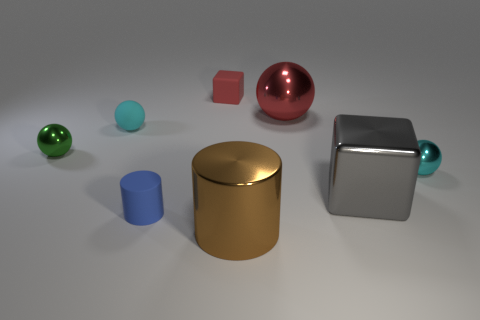Subtract all cyan shiny spheres. How many spheres are left? 3 Add 1 tiny things. How many objects exist? 9 Subtract all red balls. How many balls are left? 3 Subtract all gray blocks. How many cyan balls are left? 2 Subtract 1 balls. How many balls are left? 3 Subtract all cylinders. How many objects are left? 6 Subtract all blue cubes. Subtract all blue cylinders. How many cubes are left? 2 Subtract all metal cylinders. Subtract all matte spheres. How many objects are left? 6 Add 4 metallic cylinders. How many metallic cylinders are left? 5 Add 4 small red rubber cubes. How many small red rubber cubes exist? 5 